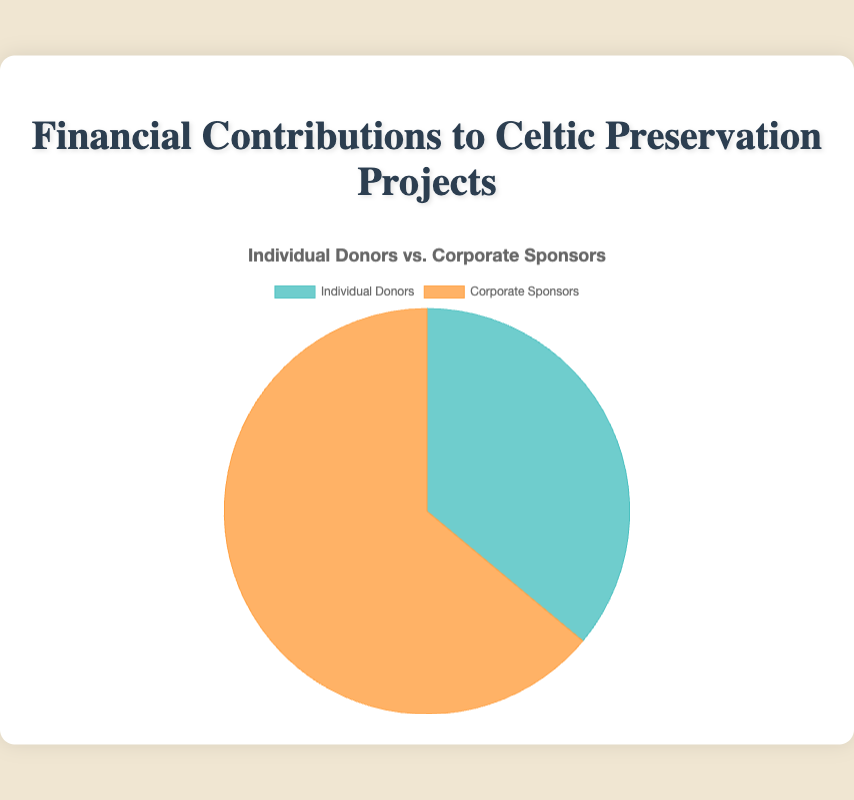What are the total financial contributions from Individual Donors? Sum the contributions of all individual donors: 150,000 (John O'Donnell) + 75,000 (Emily Byrne) + 50,000 (Michael Keane) + 25,000 (Fiona Gallagher) + 10,000 (Declan Murphy) = 310,000
Answer: 310,000 What is the percentage contribution of Corporate Sponsors to the total funds? Total contributions from Individual Donors and Corporate Sponsors are 310,000 + 550,000 = 860,000. Corporate Sponsors contribute 550,000. Therefore, the percentage is (550,000 / 860,000) * 100 = 63.95%
Answer: 63.95% Who contributed more, Individual Donors or Corporate Sponsors? Compare the total amounts: 310,000 (Individual Donors) vs. 550,000 (Corporate Sponsors). Corporate Sponsors contributed more.
Answer: Corporate Sponsors What is the difference in financial contributions between Individual Donors and Corporate Sponsors? Calculate the difference: 550,000 - 310,000 = 240,000
Answer: 240,000 Which type of contributor has the larger share of the pie chart? By observing the visual attributes, Corporate Sponsors have a larger segment as their contributions sum up to 550,000 compared to Individual Donors' 310,000.
Answer: Corporate Sponsors What is the combined contribution of the largest individual donor and the largest corporate sponsor? Largest individual donor: John O'Donnell with 150,000. Largest corporate sponsor: Celtic Heritage Foundation with 200,000. Combined: 150,000 + 200,000 = 350,000
Answer: 350,000 What color represents the Individual Donors on the pie chart? The visual attribute indicates that Individual Donors are represented by a greenish color.
Answer: Greenish Is the difference between the highest corporate contribution and highest individual contribution greater than 50,000? Highest corporate contribution: 200,000 (Celtic Heritage Foundation). Highest individual contribution: 150,000 (John O'Donnell). Difference: 200,000 - 150,000 = 50,000, which is equal to 50,000.
Answer: No What is the total amount contributed by the top 3 individual donors? Sum contributions from John O'Donnell, Emily Byrne, and Michael Keane: 150,000 + 75,000 + 50,000 = 275,000
Answer: 275,000 What is the total amount contributed by the lowest contributors from both groups? Lowest individual contribution: Declan Murphy with 10,000. Lowest corporate contributions: Scotland Preservation Group and Wales Cultural Preservation, each with 50,000. Combined: 10,000 + 50,000 + 50,000 = 110,000
Answer: 110,000 